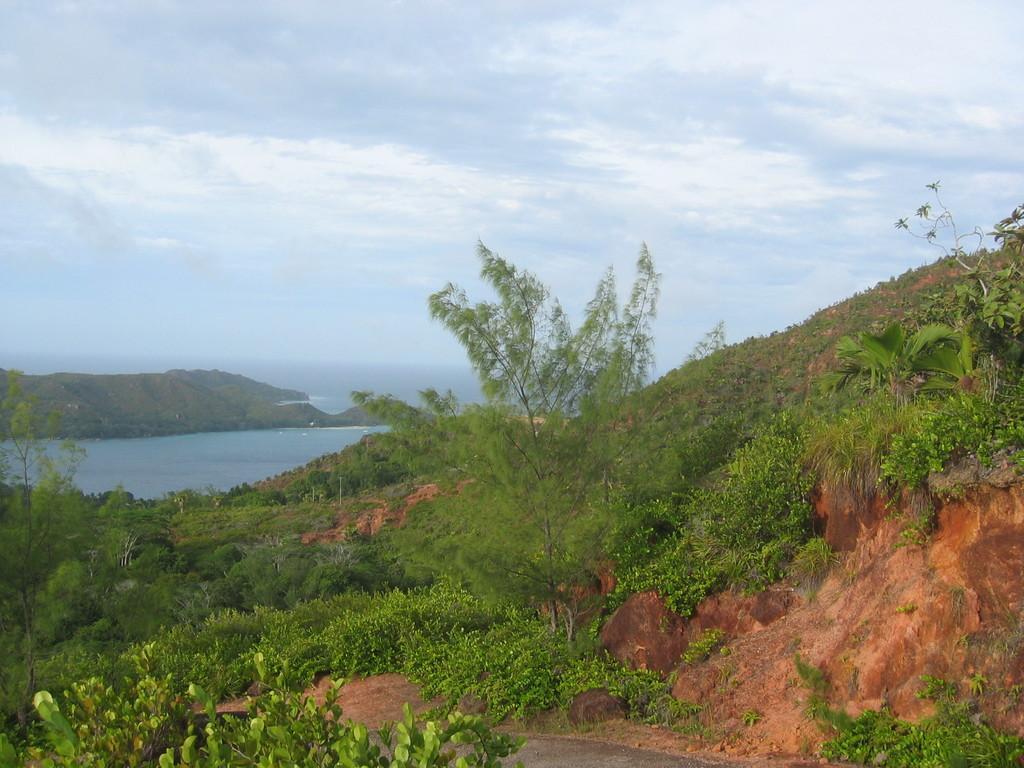How would you summarize this image in a sentence or two? The picture is taken over a hill. In the foreground of the picture there are trees, plant and rocks. In the center of the picture there are water body and hill. Sky is cloudy. 